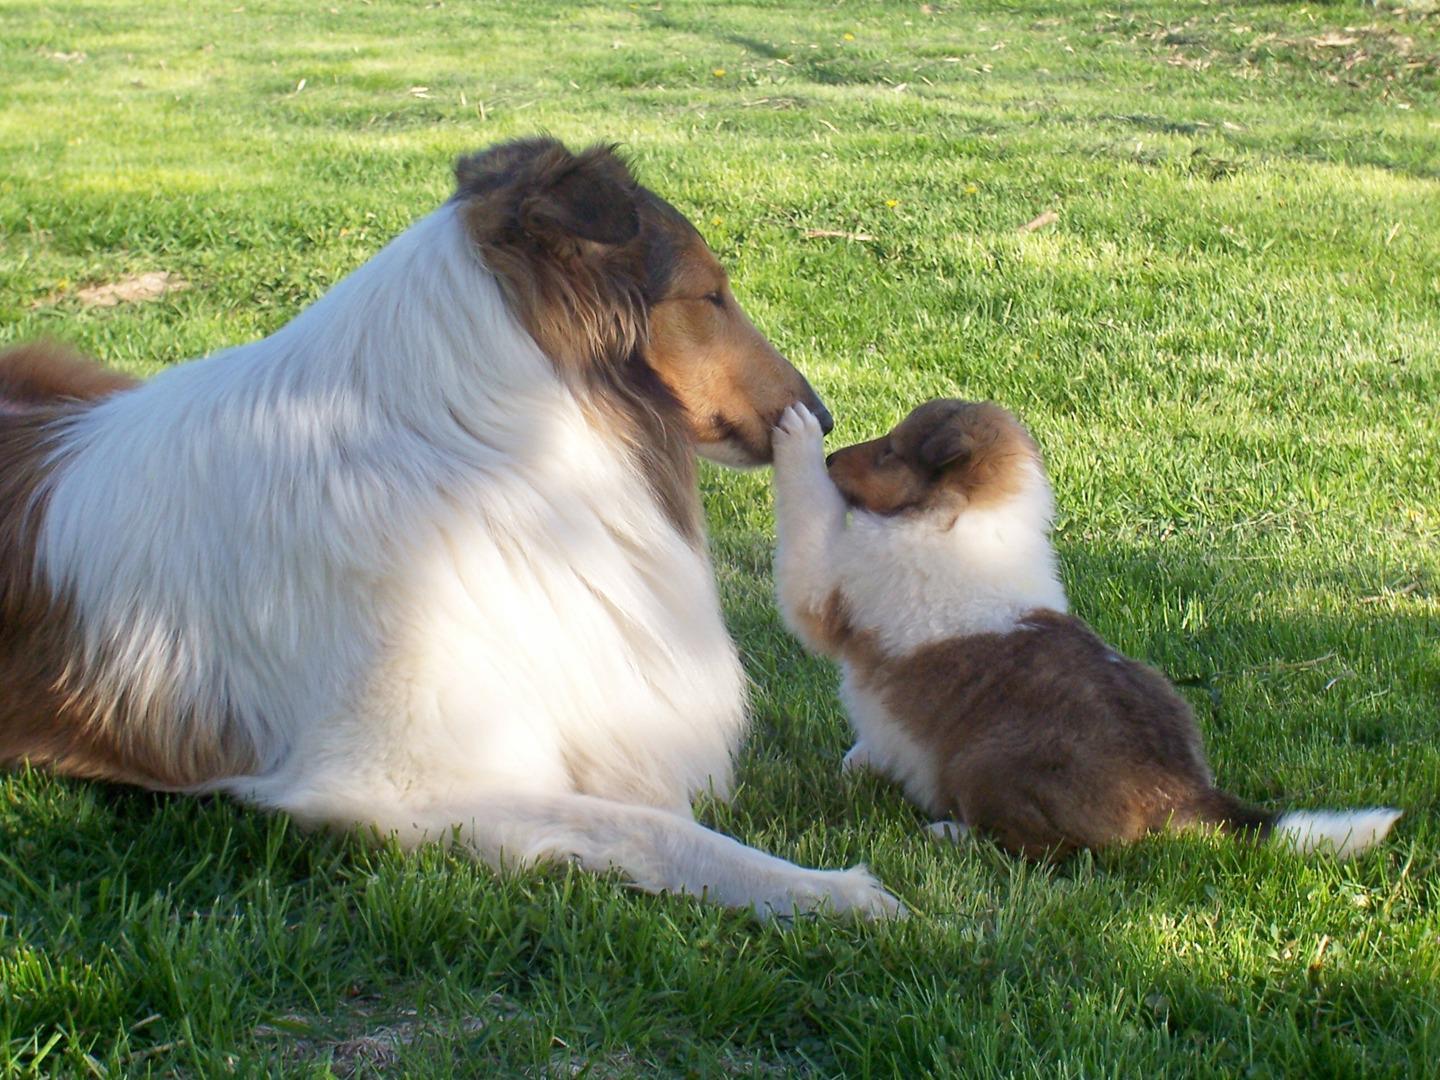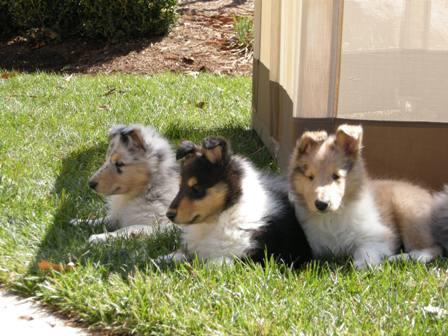The first image is the image on the left, the second image is the image on the right. Assess this claim about the two images: "The right image contains exactly one dog.". Correct or not? Answer yes or no. No. The first image is the image on the left, the second image is the image on the right. For the images shown, is this caption "There is a total of three dogs." true? Answer yes or no. No. 